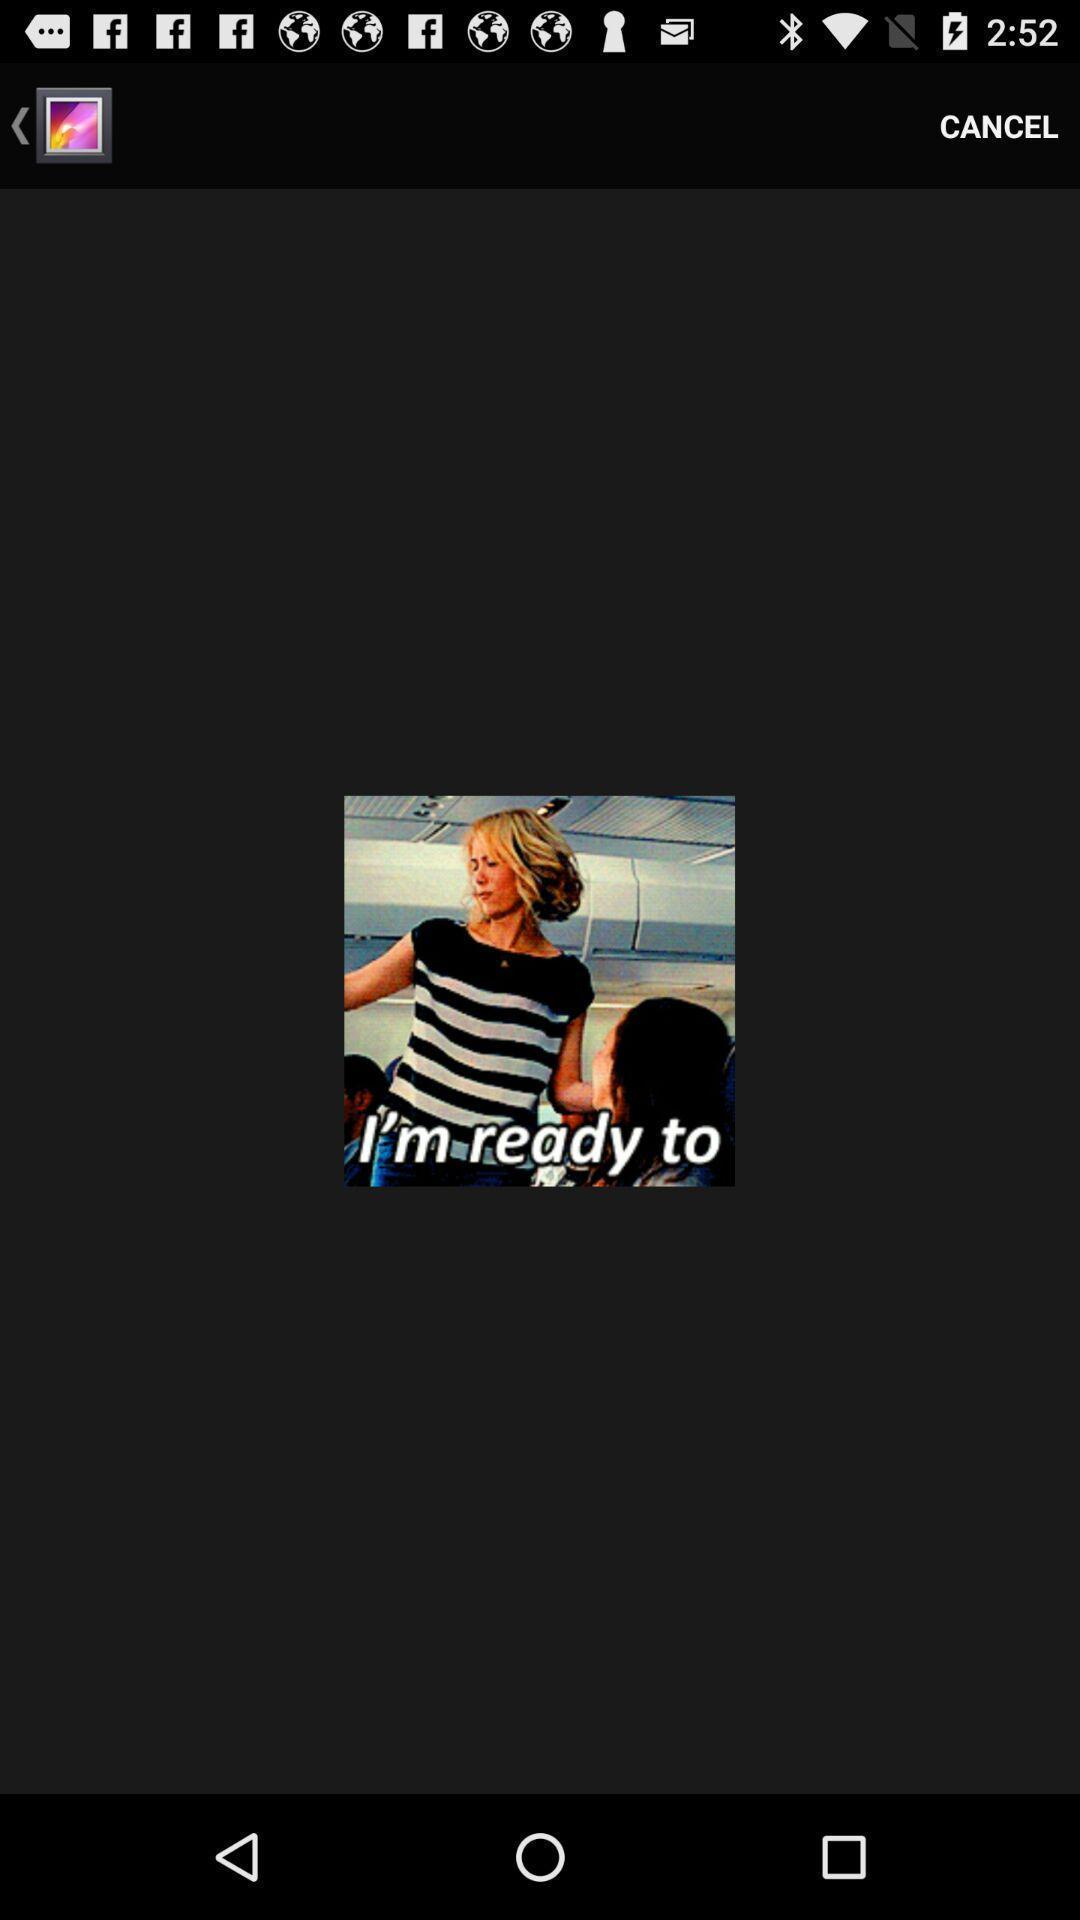Describe the key features of this screenshot. Page showing the image in gallery app. 